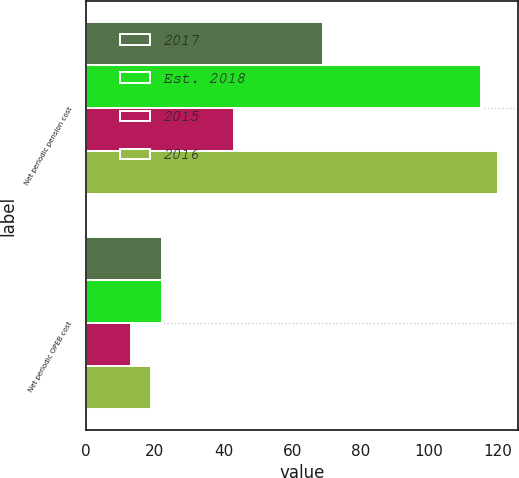<chart> <loc_0><loc_0><loc_500><loc_500><stacked_bar_chart><ecel><fcel>Net periodic pension cost<fcel>Net periodic OPEB cost<nl><fcel>2017<fcel>69<fcel>22<nl><fcel>Est. 2018<fcel>115<fcel>22<nl><fcel>2015<fcel>43<fcel>13<nl><fcel>2016<fcel>120<fcel>19<nl></chart> 